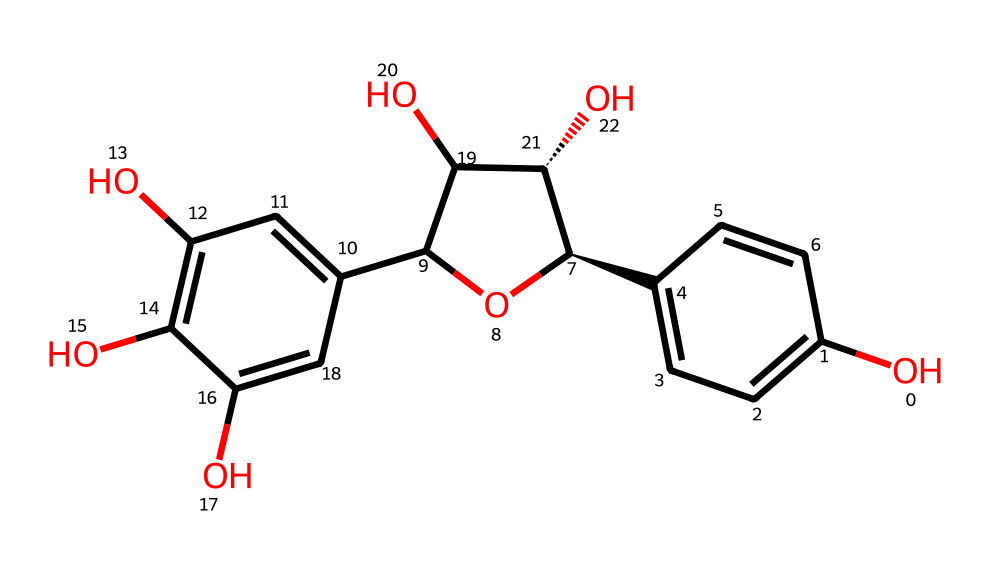What is the molecular formula of catechin? By analyzing the structure, we count the number of carbon (C), hydrogen (H), and oxygen (O) atoms present. The structural formula indicates that there are 15 carbon atoms, 14 hydrogen atoms, and 8 oxygen atoms, giving us the molecular formula C15H14O8.
Answer: C15H14O8 How many hydroxyl groups (-OH) are present in catechin? Looking closely at the structure, we identify each -OH group attached to the aromatic rings. There are a total of 5 -OH groups in the chemical structure of catechin.
Answer: 5 What type of functional groups are prominent in catechin? Analyzing the structure, we observe the presence of multiple hydroxyl (-OH) groups and an ether linkage (due to the ring structure). These indicate catechin has significant phenolic content due to the hydroxyl groups attached to aromatic systems.
Answer: hydroxyl groups, ether What is the degree of unsaturation in catechin? To determine the degree of unsaturation, we count the number of double bonds and rings in the structure. Catechin has several double bonds in its rings, contributing to the degree of unsaturation. By counting these, we find the degree of unsaturation is 7.
Answer: 7 Is catechin a flavonoid? Catechin has a structure consisting of flavan-3-ol, which is characteristic of flavonoids, specifically found within the flavanol subgroup. This structure incorporates a phenolic structure with additional hydroxyl groups.
Answer: yes What type of antioxidant activity does catechin exhibit? Catechin exhibits antioxidant activity primarily due to the presence of its hydroxyl groups that can donate electrons to free radicals, thereby stabilizing them and preventing cellular damage.
Answer: phenolic antioxidant 